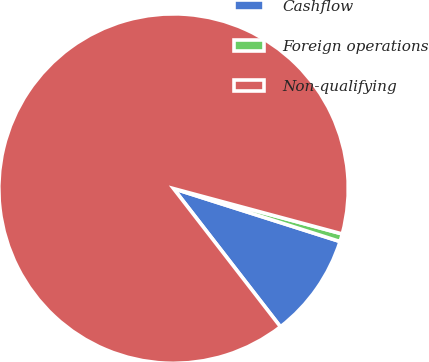<chart> <loc_0><loc_0><loc_500><loc_500><pie_chart><fcel>Cashflow<fcel>Foreign operations<fcel>Non-qualifying<nl><fcel>9.62%<fcel>0.72%<fcel>89.66%<nl></chart> 